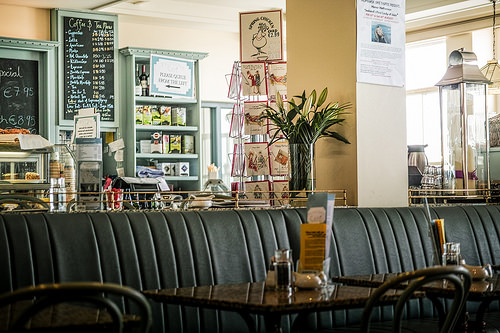<image>
Can you confirm if the table is under the plant? No. The table is not positioned under the plant. The vertical relationship between these objects is different. 